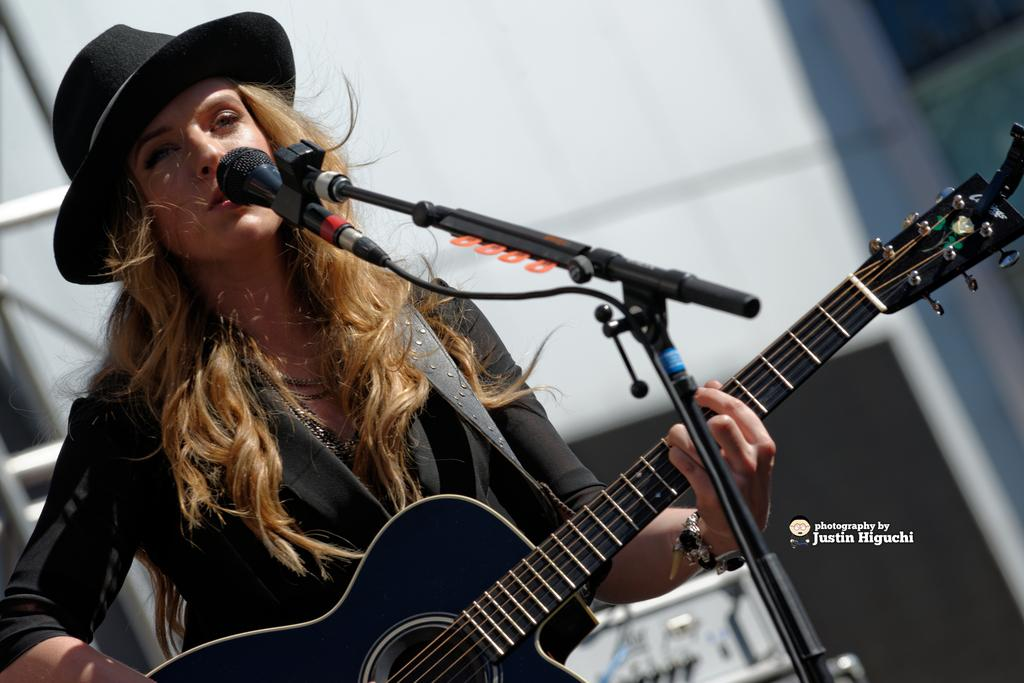Who is the main subject in the image? There is a woman in the image. What is the color of the woman's hair? The woman has blond hair. What clothing items is the woman wearing? The woman is wearing a black jacket and a black hat. What is the woman holding in the image? The woman is holding a guitar. What is the woman doing with the microphone? The woman is singing on a mic, and the microphone is held to a stand. What is the limit of spiders that can be seen in the image? There are no spiders present in the image. 